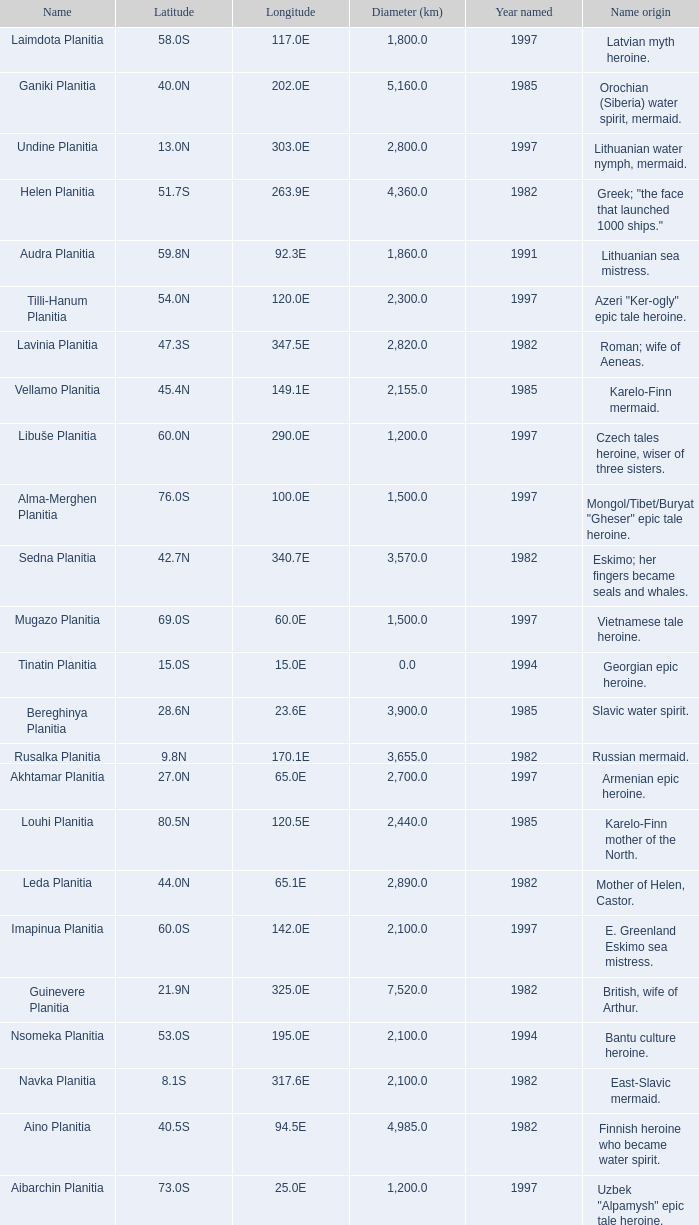What's the name origin of feature of diameter (km) 2,155.0 Karelo-Finn mermaid. 